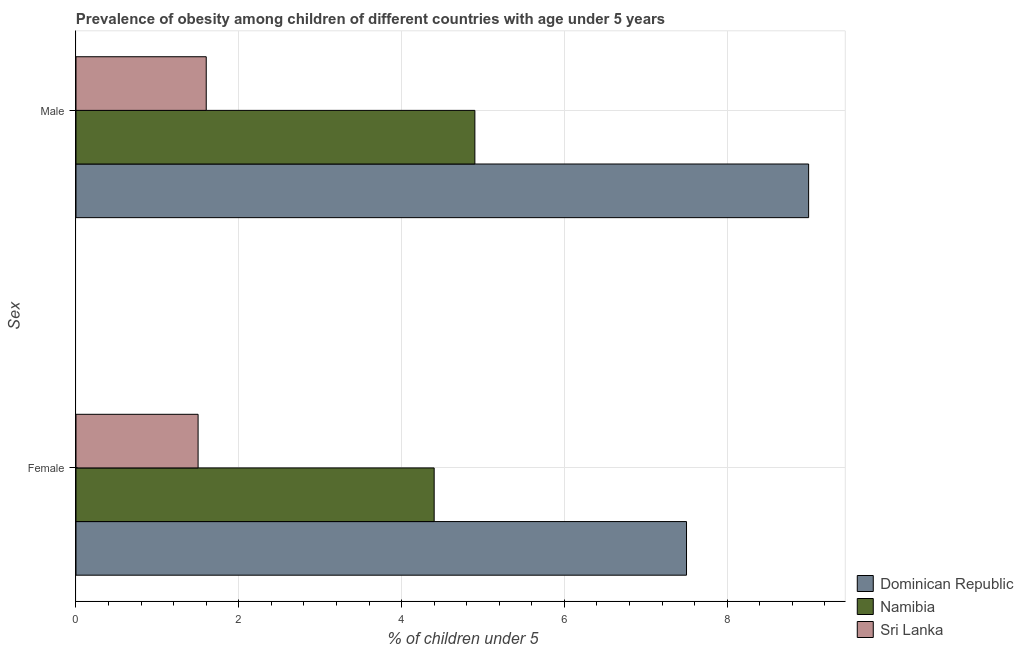How many different coloured bars are there?
Your answer should be compact. 3. How many groups of bars are there?
Make the answer very short. 2. What is the percentage of obese female children in Namibia?
Make the answer very short. 4.4. Across all countries, what is the maximum percentage of obese male children?
Your answer should be compact. 9. Across all countries, what is the minimum percentage of obese female children?
Give a very brief answer. 1.5. In which country was the percentage of obese female children maximum?
Provide a short and direct response. Dominican Republic. In which country was the percentage of obese male children minimum?
Your answer should be very brief. Sri Lanka. What is the total percentage of obese male children in the graph?
Give a very brief answer. 15.5. What is the difference between the percentage of obese male children in Dominican Republic and that in Sri Lanka?
Make the answer very short. 7.4. What is the average percentage of obese female children per country?
Your answer should be compact. 4.47. What is the difference between the percentage of obese female children and percentage of obese male children in Sri Lanka?
Your answer should be very brief. -0.1. In how many countries, is the percentage of obese female children greater than 6 %?
Your response must be concise. 1. What is the ratio of the percentage of obese male children in Dominican Republic to that in Namibia?
Your answer should be very brief. 1.84. In how many countries, is the percentage of obese female children greater than the average percentage of obese female children taken over all countries?
Your answer should be very brief. 1. What does the 2nd bar from the top in Male represents?
Ensure brevity in your answer.  Namibia. What does the 2nd bar from the bottom in Female represents?
Ensure brevity in your answer.  Namibia. Are all the bars in the graph horizontal?
Offer a very short reply. Yes. How many countries are there in the graph?
Your response must be concise. 3. What is the difference between two consecutive major ticks on the X-axis?
Provide a succinct answer. 2. Does the graph contain grids?
Offer a very short reply. Yes. Where does the legend appear in the graph?
Give a very brief answer. Bottom right. What is the title of the graph?
Make the answer very short. Prevalence of obesity among children of different countries with age under 5 years. What is the label or title of the X-axis?
Offer a terse response.  % of children under 5. What is the label or title of the Y-axis?
Provide a short and direct response. Sex. What is the  % of children under 5 of Namibia in Female?
Offer a very short reply. 4.4. What is the  % of children under 5 of Dominican Republic in Male?
Provide a short and direct response. 9. What is the  % of children under 5 of Namibia in Male?
Make the answer very short. 4.9. What is the  % of children under 5 in Sri Lanka in Male?
Your answer should be compact. 1.6. Across all Sex, what is the maximum  % of children under 5 of Dominican Republic?
Offer a terse response. 9. Across all Sex, what is the maximum  % of children under 5 in Namibia?
Ensure brevity in your answer.  4.9. Across all Sex, what is the maximum  % of children under 5 in Sri Lanka?
Provide a succinct answer. 1.6. Across all Sex, what is the minimum  % of children under 5 of Dominican Republic?
Your answer should be compact. 7.5. Across all Sex, what is the minimum  % of children under 5 in Namibia?
Offer a terse response. 4.4. Across all Sex, what is the minimum  % of children under 5 in Sri Lanka?
Offer a terse response. 1.5. What is the difference between the  % of children under 5 of Dominican Republic in Female and that in Male?
Your response must be concise. -1.5. What is the difference between the  % of children under 5 of Namibia in Female and that in Male?
Your answer should be compact. -0.5. What is the difference between the  % of children under 5 in Sri Lanka in Female and that in Male?
Your response must be concise. -0.1. What is the difference between the  % of children under 5 in Dominican Republic in Female and the  % of children under 5 in Sri Lanka in Male?
Ensure brevity in your answer.  5.9. What is the difference between the  % of children under 5 in Namibia in Female and the  % of children under 5 in Sri Lanka in Male?
Give a very brief answer. 2.8. What is the average  % of children under 5 of Dominican Republic per Sex?
Give a very brief answer. 8.25. What is the average  % of children under 5 of Namibia per Sex?
Make the answer very short. 4.65. What is the average  % of children under 5 of Sri Lanka per Sex?
Keep it short and to the point. 1.55. What is the difference between the  % of children under 5 of Dominican Republic and  % of children under 5 of Namibia in Female?
Give a very brief answer. 3.1. What is the difference between the  % of children under 5 in Dominican Republic and  % of children under 5 in Sri Lanka in Male?
Provide a short and direct response. 7.4. What is the ratio of the  % of children under 5 in Dominican Republic in Female to that in Male?
Offer a very short reply. 0.83. What is the ratio of the  % of children under 5 in Namibia in Female to that in Male?
Give a very brief answer. 0.9. What is the ratio of the  % of children under 5 in Sri Lanka in Female to that in Male?
Offer a terse response. 0.94. What is the difference between the highest and the second highest  % of children under 5 of Dominican Republic?
Your response must be concise. 1.5. What is the difference between the highest and the second highest  % of children under 5 in Sri Lanka?
Offer a terse response. 0.1. What is the difference between the highest and the lowest  % of children under 5 in Dominican Republic?
Keep it short and to the point. 1.5. 